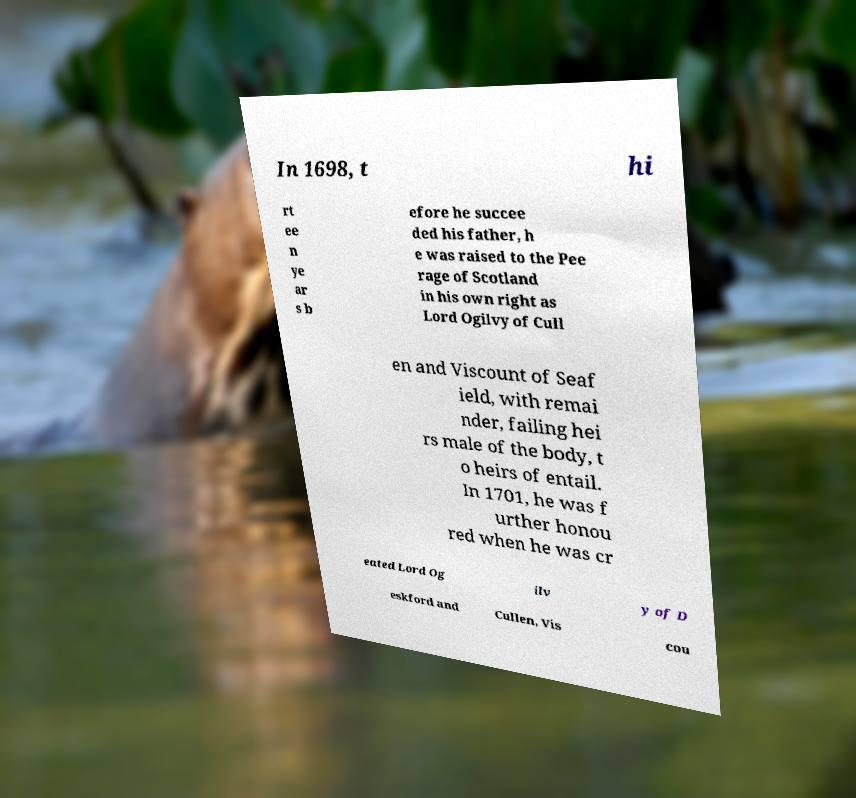Could you assist in decoding the text presented in this image and type it out clearly? In 1698, t hi rt ee n ye ar s b efore he succee ded his father, h e was raised to the Pee rage of Scotland in his own right as Lord Ogilvy of Cull en and Viscount of Seaf ield, with remai nder, failing hei rs male of the body, t o heirs of entail. In 1701, he was f urther honou red when he was cr eated Lord Og ilv y of D eskford and Cullen, Vis cou 